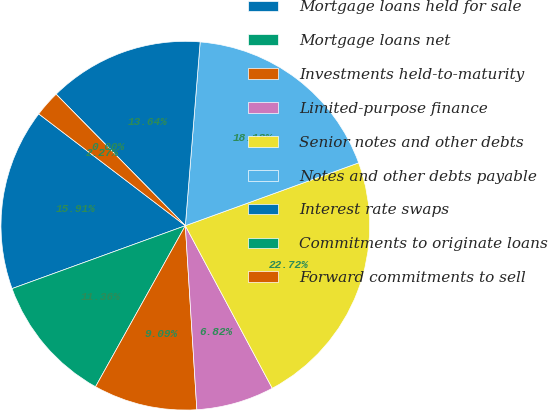Convert chart. <chart><loc_0><loc_0><loc_500><loc_500><pie_chart><fcel>Mortgage loans held for sale<fcel>Mortgage loans net<fcel>Investments held-to-maturity<fcel>Limited-purpose finance<fcel>Senior notes and other debts<fcel>Notes and other debts payable<fcel>Interest rate swaps<fcel>Commitments to originate loans<fcel>Forward commitments to sell<nl><fcel>15.91%<fcel>11.36%<fcel>9.09%<fcel>6.82%<fcel>22.72%<fcel>18.18%<fcel>13.64%<fcel>0.0%<fcel>2.27%<nl></chart> 